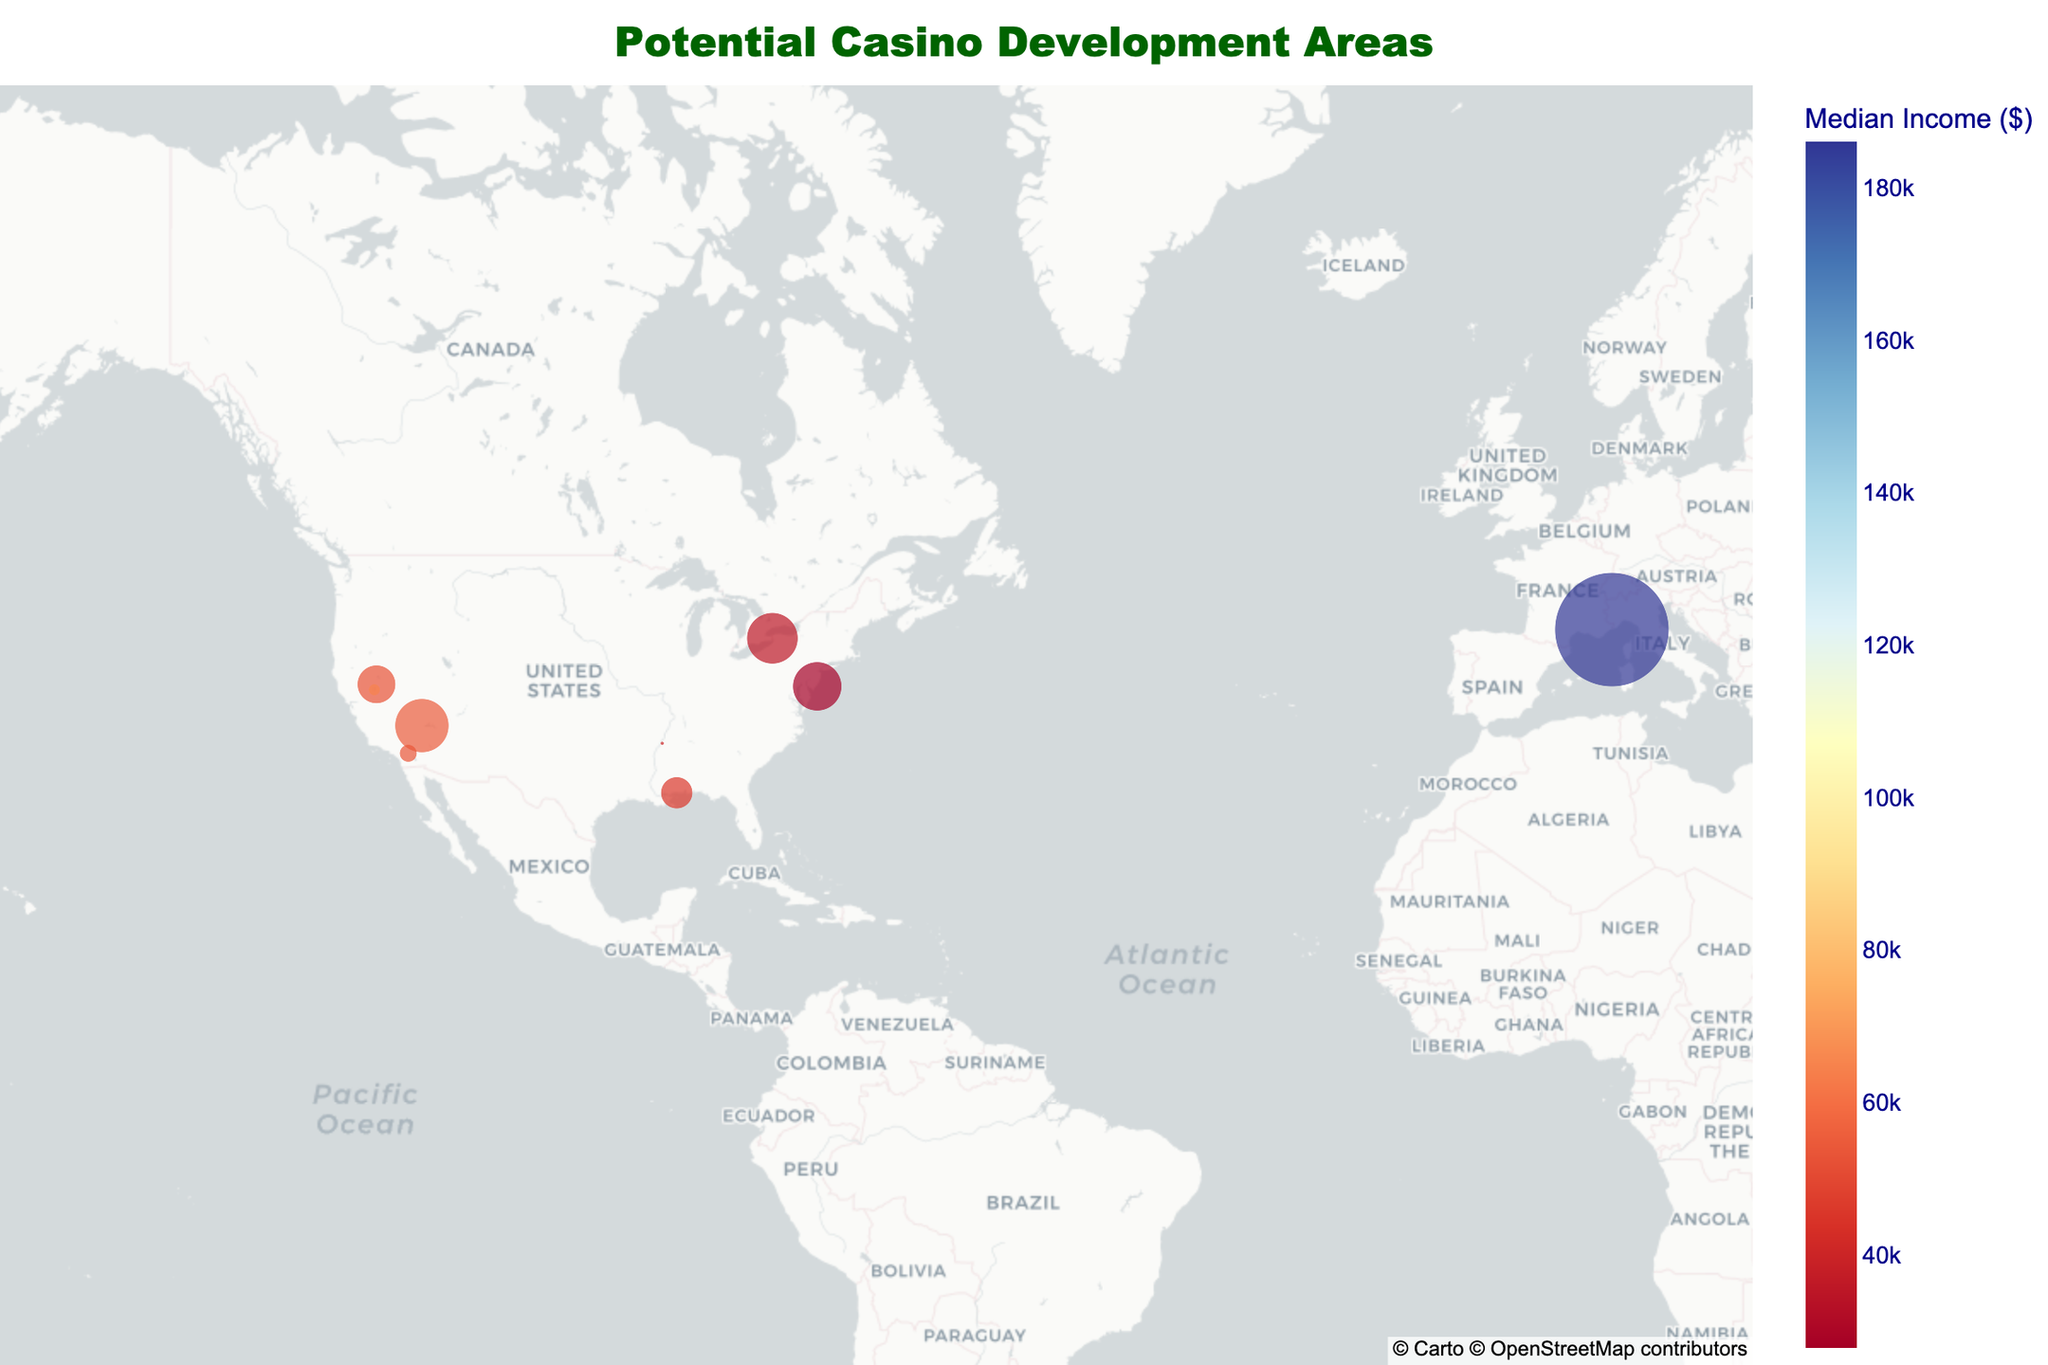What's the title of the plot? The title is usually located at the top center of the plot. It is presented in larger font size and often summarizes the purpose of the plot.
Answer: "Potential Casino Development Areas" How many data points are represented on the map? By counting the individual scatter points on the map, you can determine the number of locations plotted.
Answer: 10 Which city has the highest median income? Look at the color bar to identify the color indicating the highest median income and find the corresponding data point.
Answer: Monte Carlo, Monaco What is the population density of Atlantic City, New Jersey? Use the hover feature to find Atlantic City and observe the population density value presented.
Answer: 3552/km² Which city has the lowest population density represented on the map? Look for the smallest size data point as population density is mapped to size. Hover over each of those points if necessary.
Answer: Tunica, Mississippi Compare the median income of Las Vegas, Nevada and Reno, Nevada. Which one is higher? Use the hover feature to find the median incomes of both cities and compare their values.
Answer: Las Vegas, Nevada Which city has a larger population density: Niagara Falls, New York, or Biloxi, Mississippi? Use the hover feature to find the population densities of both cities and compare their values.
Answer: Niagara Falls, New York What is the range of median incomes displayed on the plot? Use the color bar axis to identify the minimum and maximum values of the median incomes represented.
Answer: $18,680 to $186,080 Which city is located furthest west on the map? By looking at the longitudinal axis, find the city with the highest longitude value, which is furthest to the left on the plot.
Answer: Las Vegas, Nevada What are the median income and population density of Macau, China? Use the hover feature to find Macau, China and note the values of median income and population density presented.
Answer: Median Income: $34,441, Population Density: 21,340/km² 